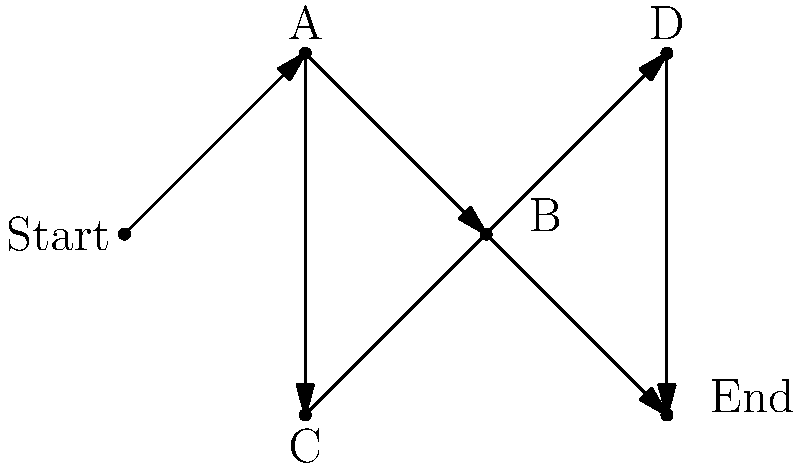In the context of non-linear narrative structures, analyze the branching story diagram provided. Which narrative technique does this structure most closely resemble, and how might it enhance the storytelling experience in an indie film? To answer this question, let's break down the analysis step-by-step:

1. Observe the structure: The diagram shows a branching narrative with multiple paths from start to end.

2. Identify key features:
   - There's a single starting point (labeled "Start")
   - The story branches at point A into two paths (B and C)
   - Both paths converge at point D before reaching the end
   - There's also a direct path from B to the end, bypassing D

3. Recognize the narrative technique: This structure most closely resembles a "Parallel Narratives" or "Multilinear Narrative" technique.

4. Understanding Parallel Narratives:
   - Multiple storylines that can be experienced separately
   - Stories may intersect or influence each other
   - Allows for different perspectives or timelines of the same event

5. Enhancing storytelling in indie films:
   - Offers audience agency in story progression
   - Creates replay value as viewers can experience different paths
   - Allows for exploration of "what-if" scenarios
   - Can represent different character perspectives or timelines
   - Challenges traditional linear storytelling conventions

6. Application in indie filmmaking:
   - Can be implemented through interactive media (e.g., web-based films)
   - Or through clever editing and narrative structure in traditional film format
   - Aligns with indie ethos of experimentation and pushing boundaries

This structure enhances storytelling by offering a more immersive and personalized experience, challenging audience expectations, and potentially increasing engagement through multiple viewings.
Answer: Parallel Narratives; enhances storytelling by offering multiple perspectives, audience agency, and increased replay value. 